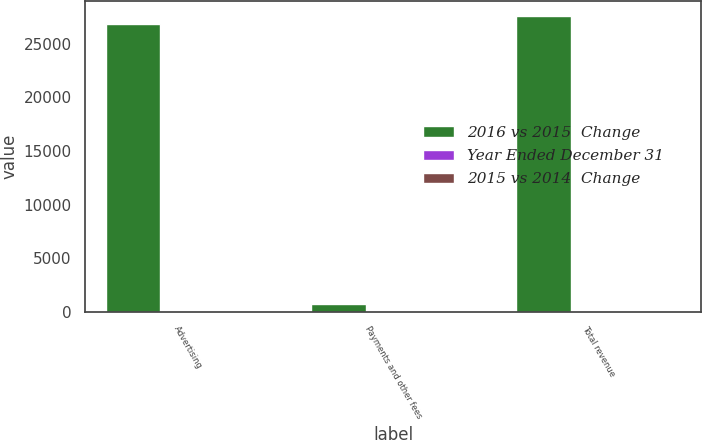Convert chart to OTSL. <chart><loc_0><loc_0><loc_500><loc_500><stacked_bar_chart><ecel><fcel>Advertising<fcel>Payments and other fees<fcel>Total revenue<nl><fcel>2016 vs 2015  Change<fcel>26885<fcel>753<fcel>27638<nl><fcel>Year Ended December 31<fcel>57<fcel>11<fcel>54<nl><fcel>2015 vs 2014  Change<fcel>49<fcel>13<fcel>44<nl></chart> 